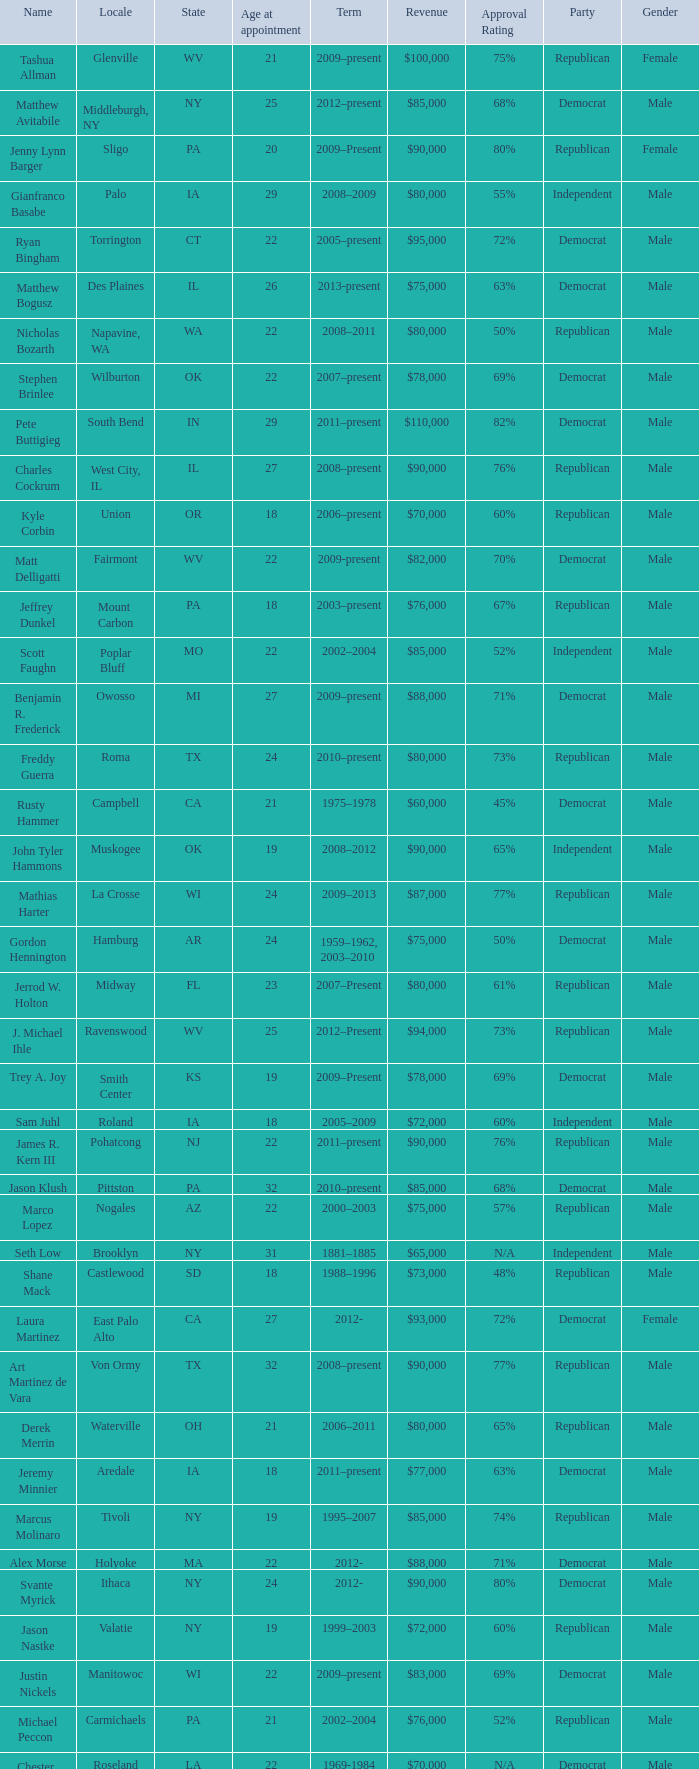What is the name of the holland locale Philip A. Tanis. 